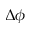<formula> <loc_0><loc_0><loc_500><loc_500>\Delta \phi</formula> 